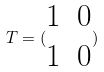Convert formula to latex. <formula><loc_0><loc_0><loc_500><loc_500>T = ( \begin{matrix} 1 & 0 \\ 1 & 0 \end{matrix} )</formula> 